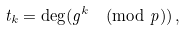<formula> <loc_0><loc_0><loc_500><loc_500>t _ { k } = \deg ( g ^ { k } \pmod { p } ) \, ,</formula> 